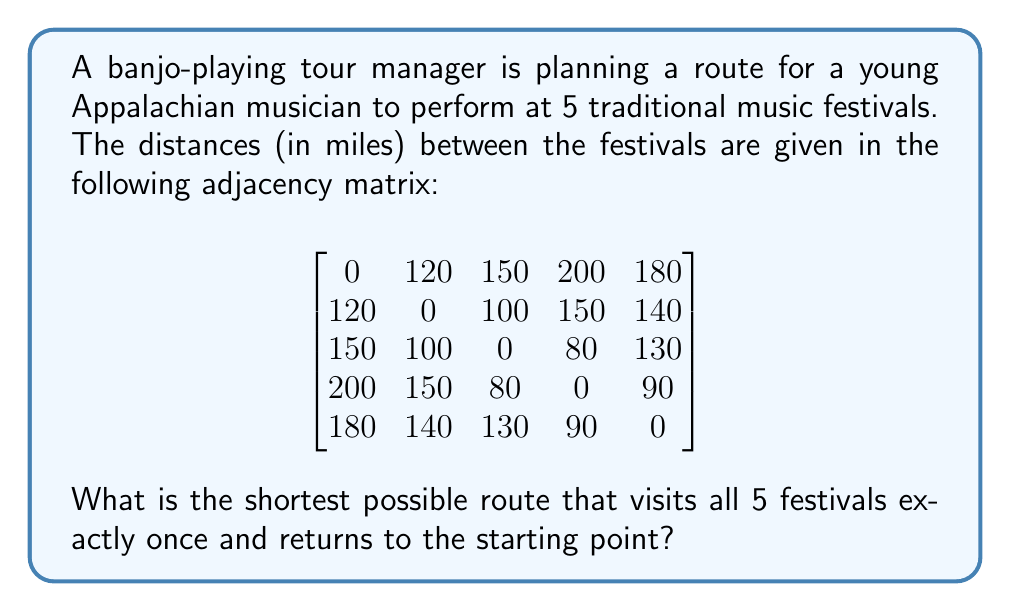Help me with this question. To solve this problem, we need to find the shortest Hamiltonian cycle in the given graph. This is known as the Traveling Salesman Problem (TSP). For a small number of vertices like in this case, we can use a brute-force approach to find the optimal solution.

Steps:
1. List all possible permutations of the 5 festivals (excluding the starting point).
2. For each permutation, calculate the total distance of the tour, including the return to the starting point.
3. Choose the permutation with the smallest total distance.

There are 4! = 24 possible permutations to check. Let's number the festivals from 1 to 5.

For example, one possible route is 1-2-3-4-5-1:
Distance = 120 + 100 + 80 + 90 + 180 = 570 miles

Another route could be 1-3-2-5-4-1:
Distance = 150 + 100 + 140 + 90 + 200 = 680 miles

After checking all permutations, we find that the shortest route is:

1-2-5-4-3-1

The distance for this route is:
120 (1-2) + 140 (2-5) + 90 (5-4) + 80 (4-3) + 150 (3-1) = 580 miles

This route minimizes the total distance while visiting all festivals exactly once and returning to the starting point.
Answer: The shortest possible route is 1-2-5-4-3-1, with a total distance of 580 miles. 